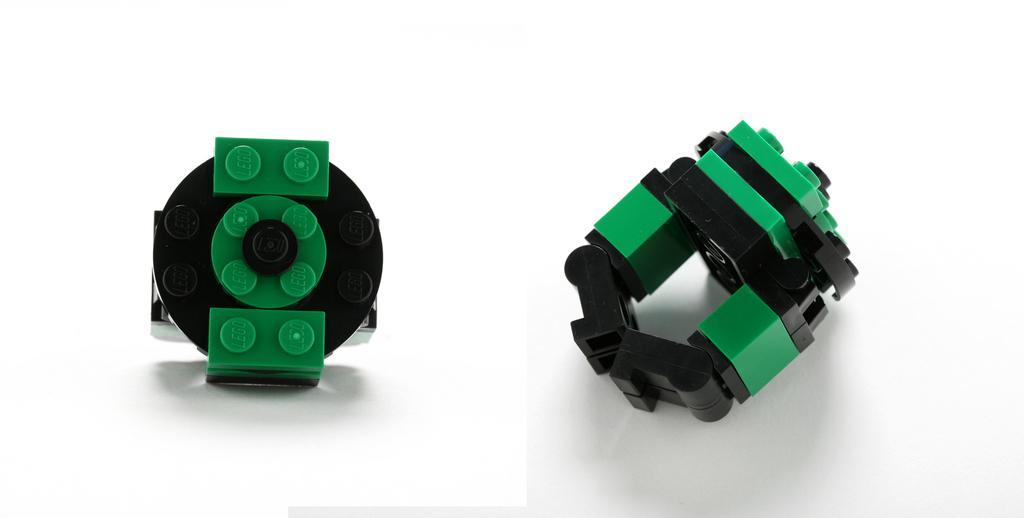How many toys are present in the image? There are two toys in the image. What can be seen in the background of the image? The background of the image is white. What type of bait is used to catch fish in the image? There is no mention of fish or bait in the image; it only features two toys. 